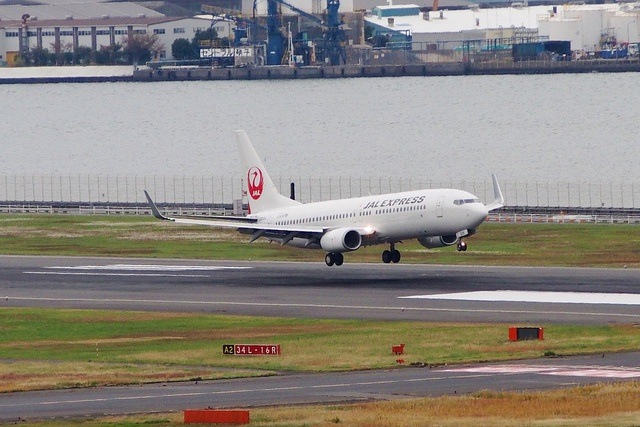Describe the objects in this image and their specific colors. I can see airplane in darkgray, lightgray, black, and gray tones, truck in darkgray, darkblue, gray, and navy tones, and truck in darkgray, gray, and blue tones in this image. 